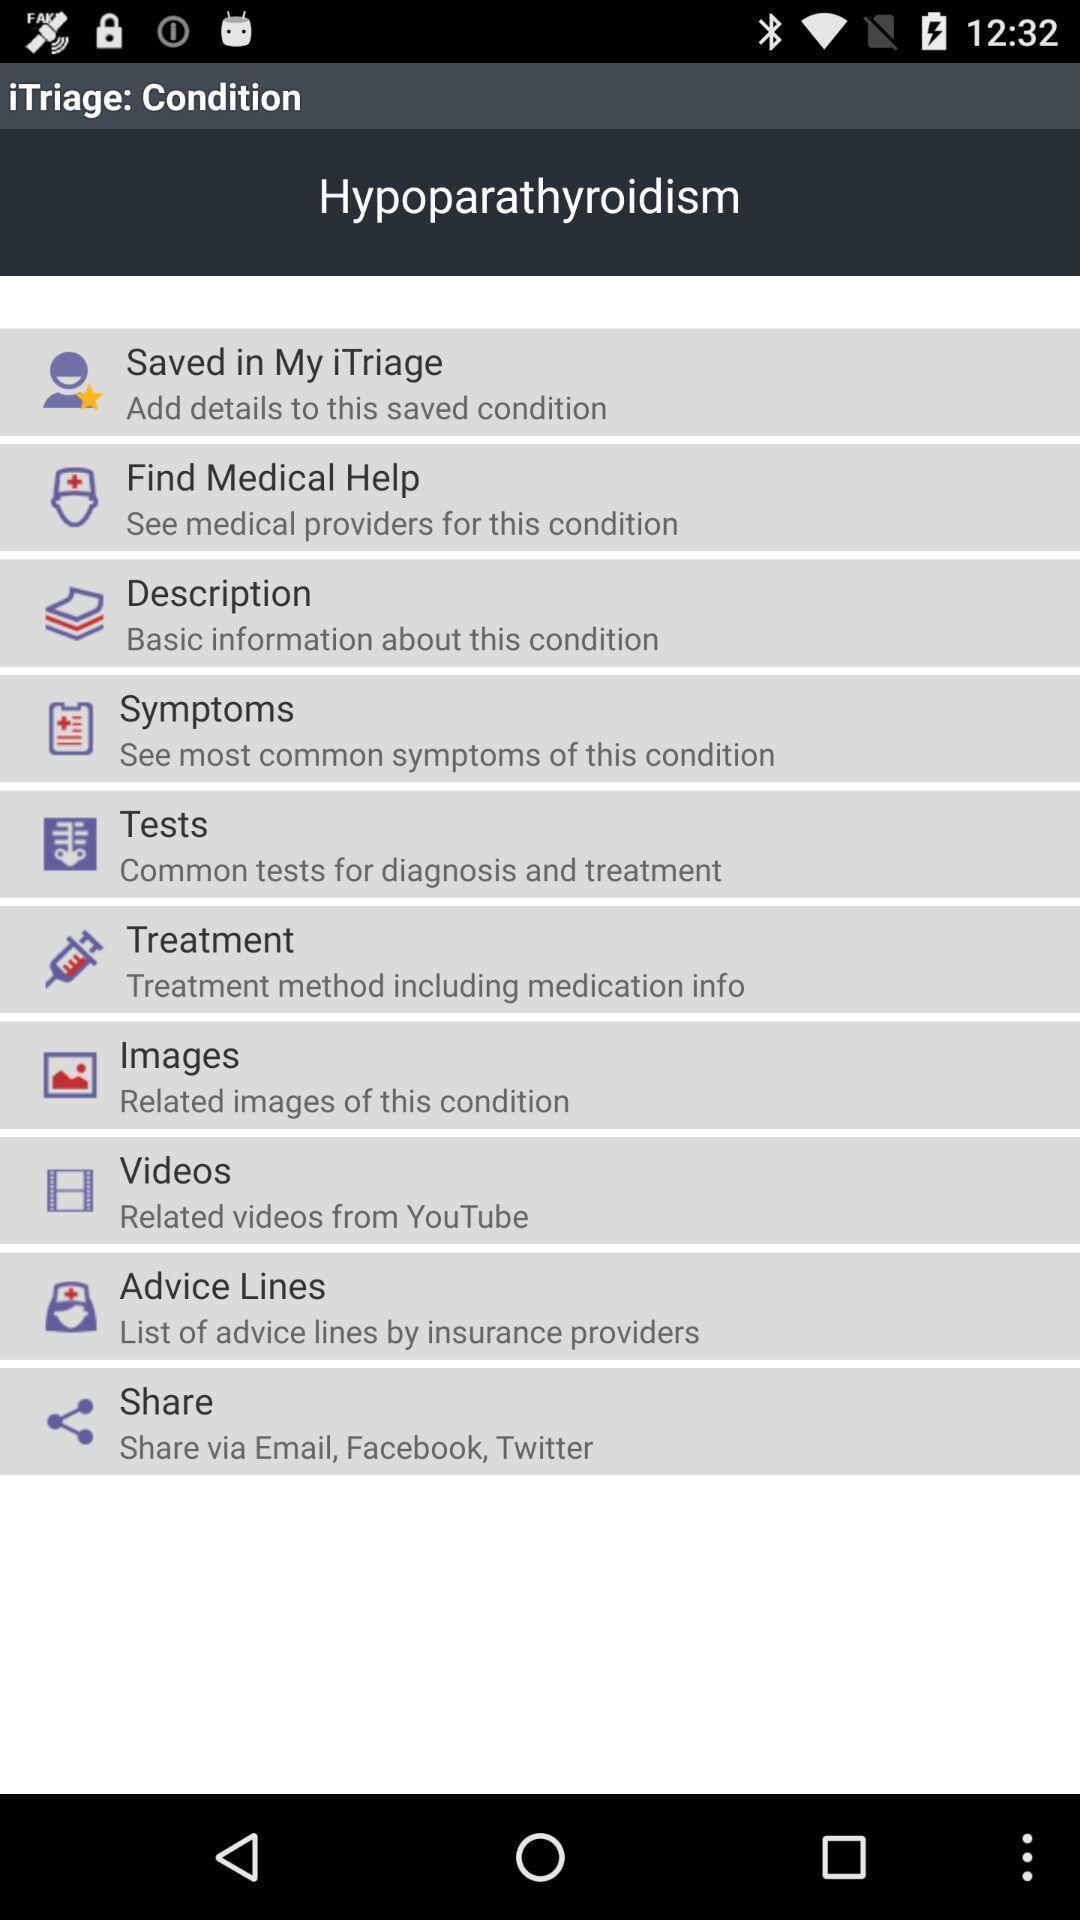What can you discern from this picture? Page showing various options of a health care app. 